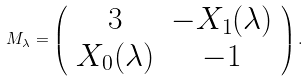<formula> <loc_0><loc_0><loc_500><loc_500>M _ { \lambda } = \left ( \begin{array} { c c } 3 & - X _ { 1 } ( \lambda ) \\ X _ { 0 } ( \lambda ) & - 1 \end{array} \right ) .</formula> 